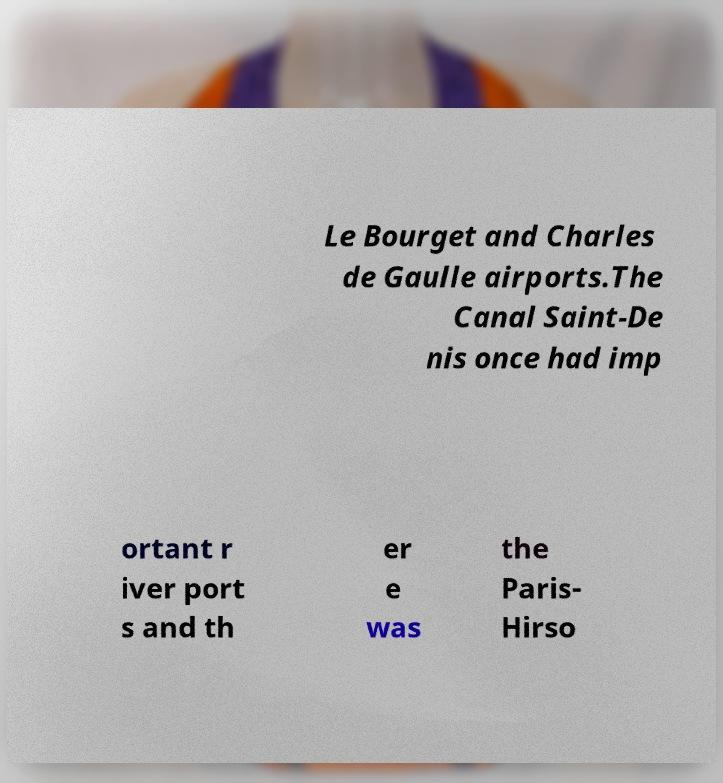Can you read and provide the text displayed in the image?This photo seems to have some interesting text. Can you extract and type it out for me? Le Bourget and Charles de Gaulle airports.The Canal Saint-De nis once had imp ortant r iver port s and th er e was the Paris- Hirso 